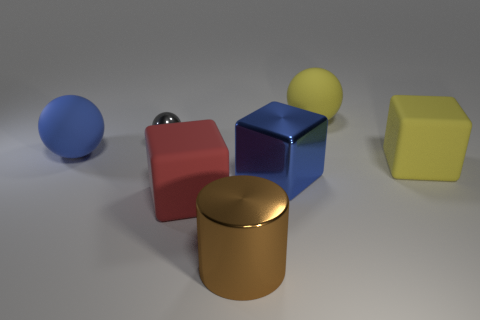Add 1 large balls. How many objects exist? 8 Subtract all spheres. How many objects are left? 4 Subtract 0 green cubes. How many objects are left? 7 Subtract all tiny gray shiny balls. Subtract all big brown metallic objects. How many objects are left? 5 Add 3 brown cylinders. How many brown cylinders are left? 4 Add 4 red objects. How many red objects exist? 5 